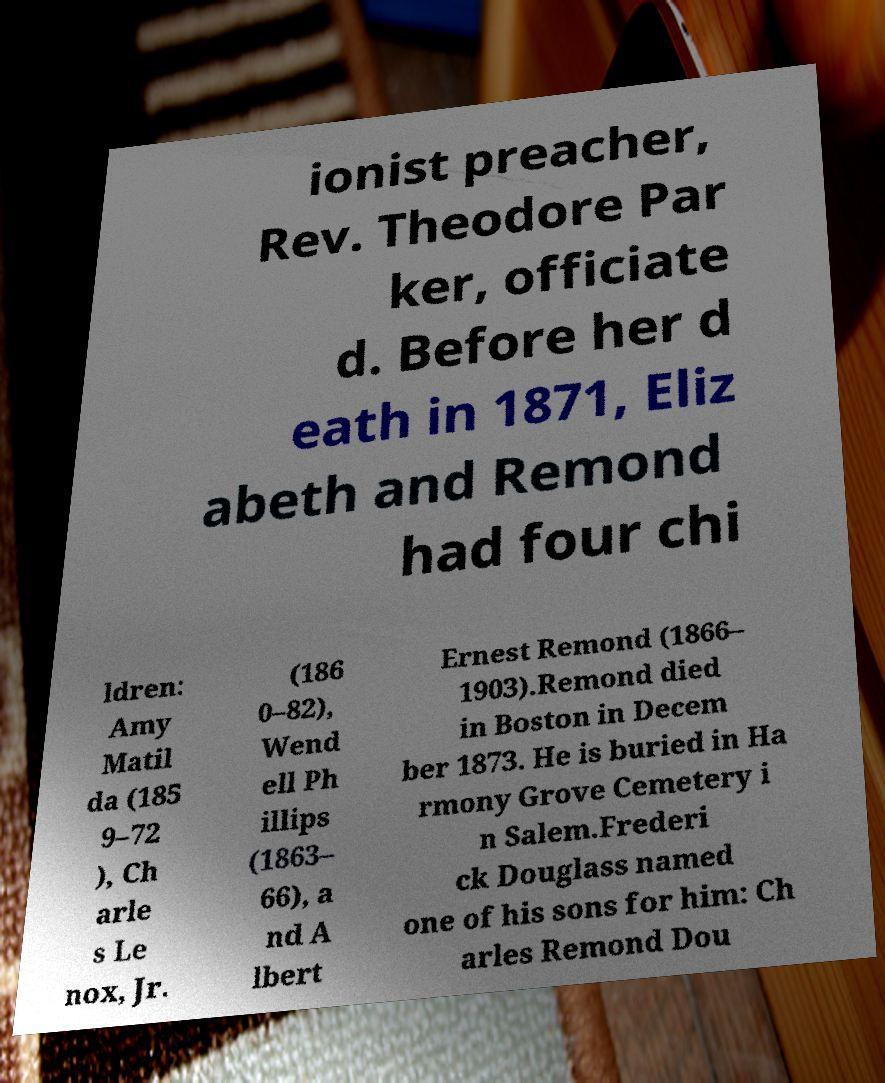Can you accurately transcribe the text from the provided image for me? ionist preacher, Rev. Theodore Par ker, officiate d. Before her d eath in 1871, Eliz abeth and Remond had four chi ldren: Amy Matil da (185 9–72 ), Ch arle s Le nox, Jr. (186 0–82), Wend ell Ph illips (1863– 66), a nd A lbert Ernest Remond (1866– 1903).Remond died in Boston in Decem ber 1873. He is buried in Ha rmony Grove Cemetery i n Salem.Frederi ck Douglass named one of his sons for him: Ch arles Remond Dou 